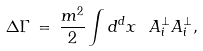Convert formula to latex. <formula><loc_0><loc_0><loc_500><loc_500>\Delta \Gamma \, = \, \frac { m ^ { 2 } } { 2 } \int d ^ { d } x \ A ^ { \perp } _ { i } A ^ { \perp } _ { i } ,</formula> 